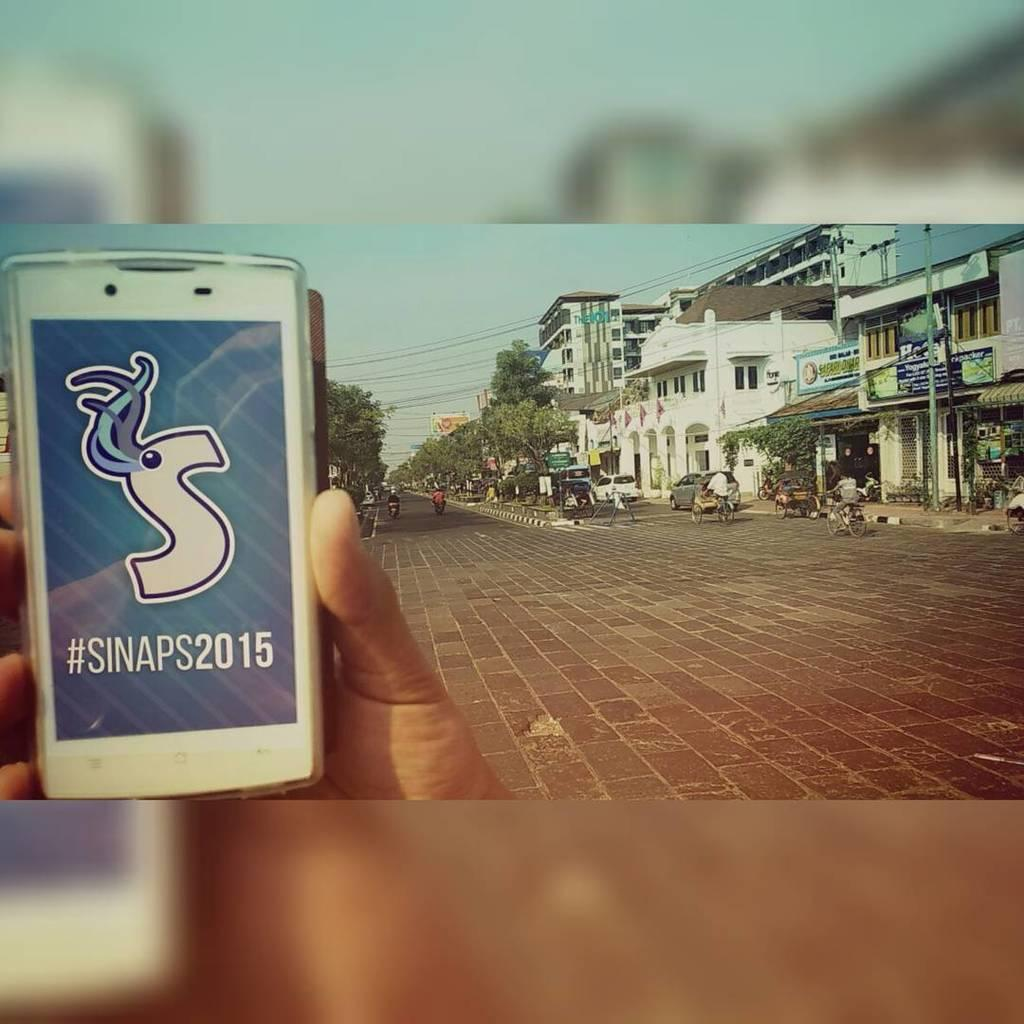<image>
Render a clear and concise summary of the photo. a cellphone reading Sinaps 2015 held over a brick road 